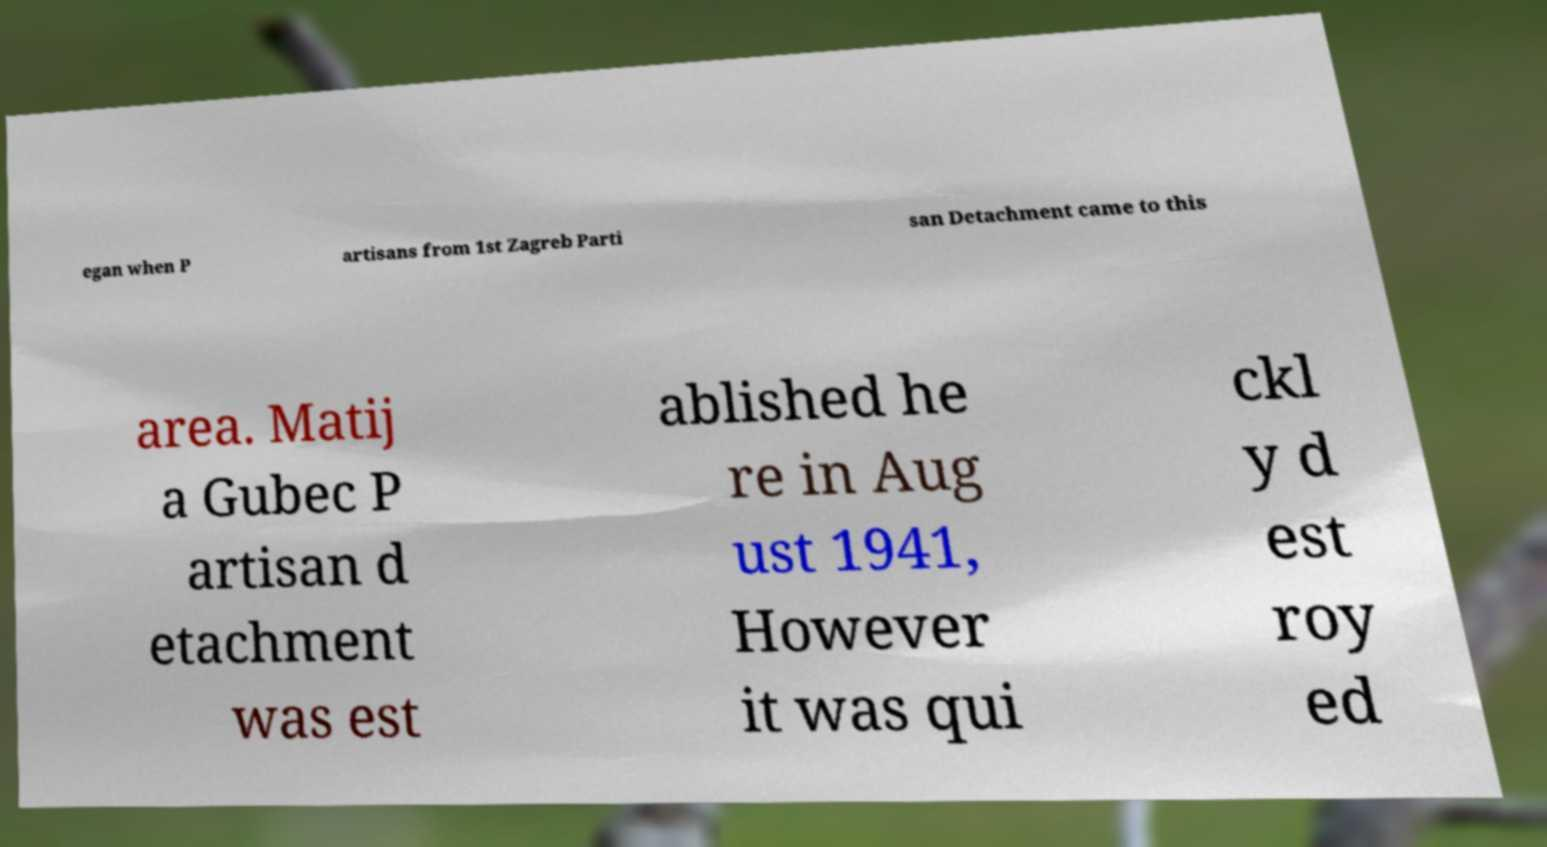For documentation purposes, I need the text within this image transcribed. Could you provide that? egan when P artisans from 1st Zagreb Parti san Detachment came to this area. Matij a Gubec P artisan d etachment was est ablished he re in Aug ust 1941, However it was qui ckl y d est roy ed 